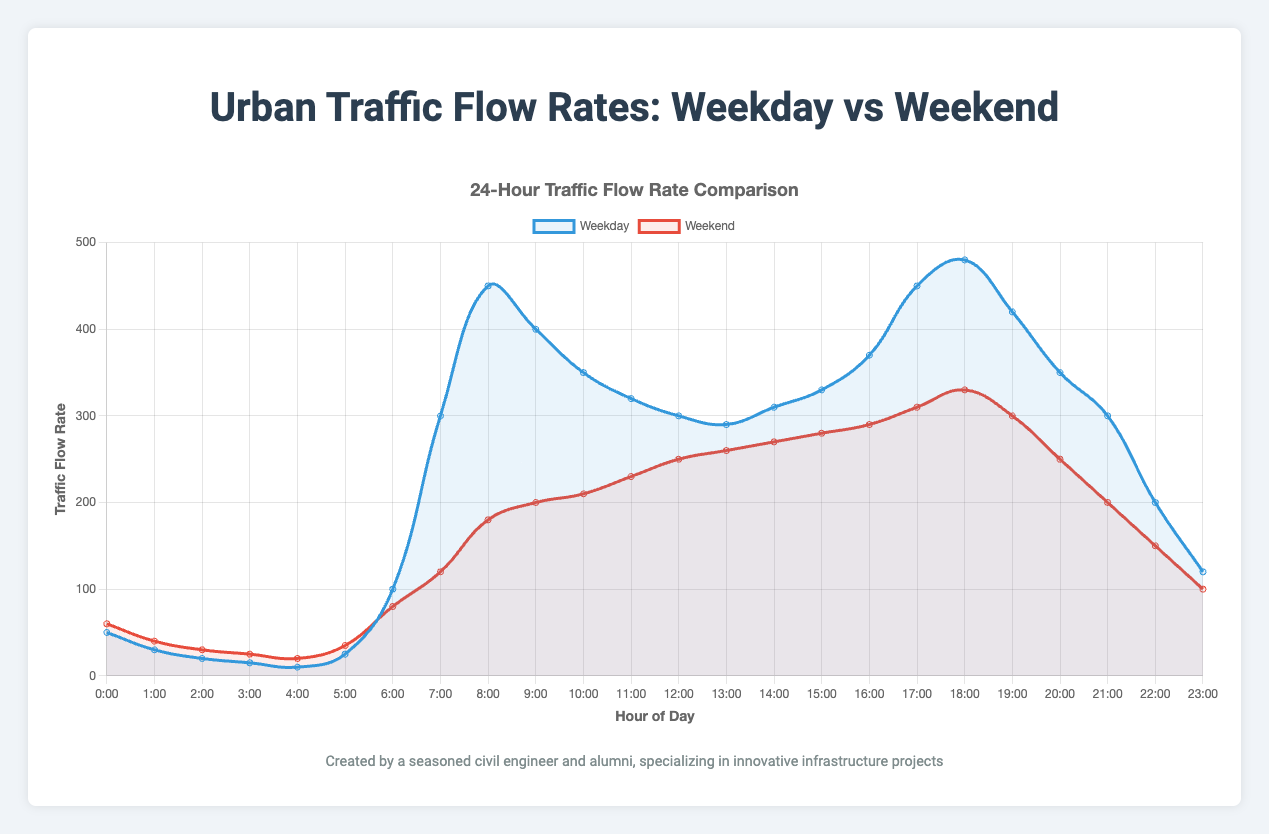What time has the lowest traffic flow rate on weekdays? The graph shows the traffic flow rate versus time on weekdays. The lowest rate is at 4 AM where the traffic flow rate is 10.
Answer: 4 AM During which hour is the maximum traffic flow rate observed on the weekends? By observing the peak points on the weekend traffic flow line, the maximum traffic flow rate is at 330 which occurs at 6 PM.
Answer: 6 PM How does the traffic flow rate at 8 AM on weekdays compare to weekends? At 8 AM, the traffic flow rate on weekdays is 450, while on weekends, it is 180. Weekday traffic is higher than weekend traffic at this hour.
Answer: Weekdays higher What is the sum of traffic flow rates at 9 AM and 5 PM on weekdays? Referring to the traffic flow rates at 9 AM (400) and 5 PM (450) on weekdays, their sum is 850.
Answer: 850 Compare the traffic flow rates between 6 PM and 7 PM on weekends. On weekends at 6 PM, the traffic flow rate is 330, and at 7 PM it is 300. Therefore, the rate decreases from 6 PM to 7 PM.
Answer: Decreases What is the average traffic flow rate between 4 AM to 8 AM on weekends? The traffic flow rates between 4 AM and 8 AM are 20, 35, 80, 120, and 180. The sum is 435, divided by 5 hours gives an average of 87.
Answer: 87 Which time period shows a steeper increase in traffic flow rate: 5 AM to 8 AM on weekdays or weekends? For weekdays, the increase is from 25 to 450 (425 units) in 3 hours. For weekends, it's from 35 to 180 (145 units) in 3 hours. The weekday period shows a steeper increase.
Answer: Weekdays What is the difference in traffic flow rate between 5 PM and 10 PM on weekdays? The traffic flow rate at 5 PM is 450, and at 10 PM is 200. The difference is 450 - 200 = 250.
Answer: 250 Between the hours of 6 PM and 9 PM, which day type shows more consistent traffic flow rates? On weekdays, the traffic flow rates are 480, 420, and 350. On weekends, the rates are 330, 300, and 250. Weekends show a more consistent decrease of about 30 units per hour.
Answer: Weekends What is the traffic flow rate trend on weekdays between 2 PM and 5 PM? Observing the traffic flow rates at 2 PM (310), 3 PM (330), 4 PM (370), and 5 PM (450), there's a consistent increase in this period.
Answer: Increasing 